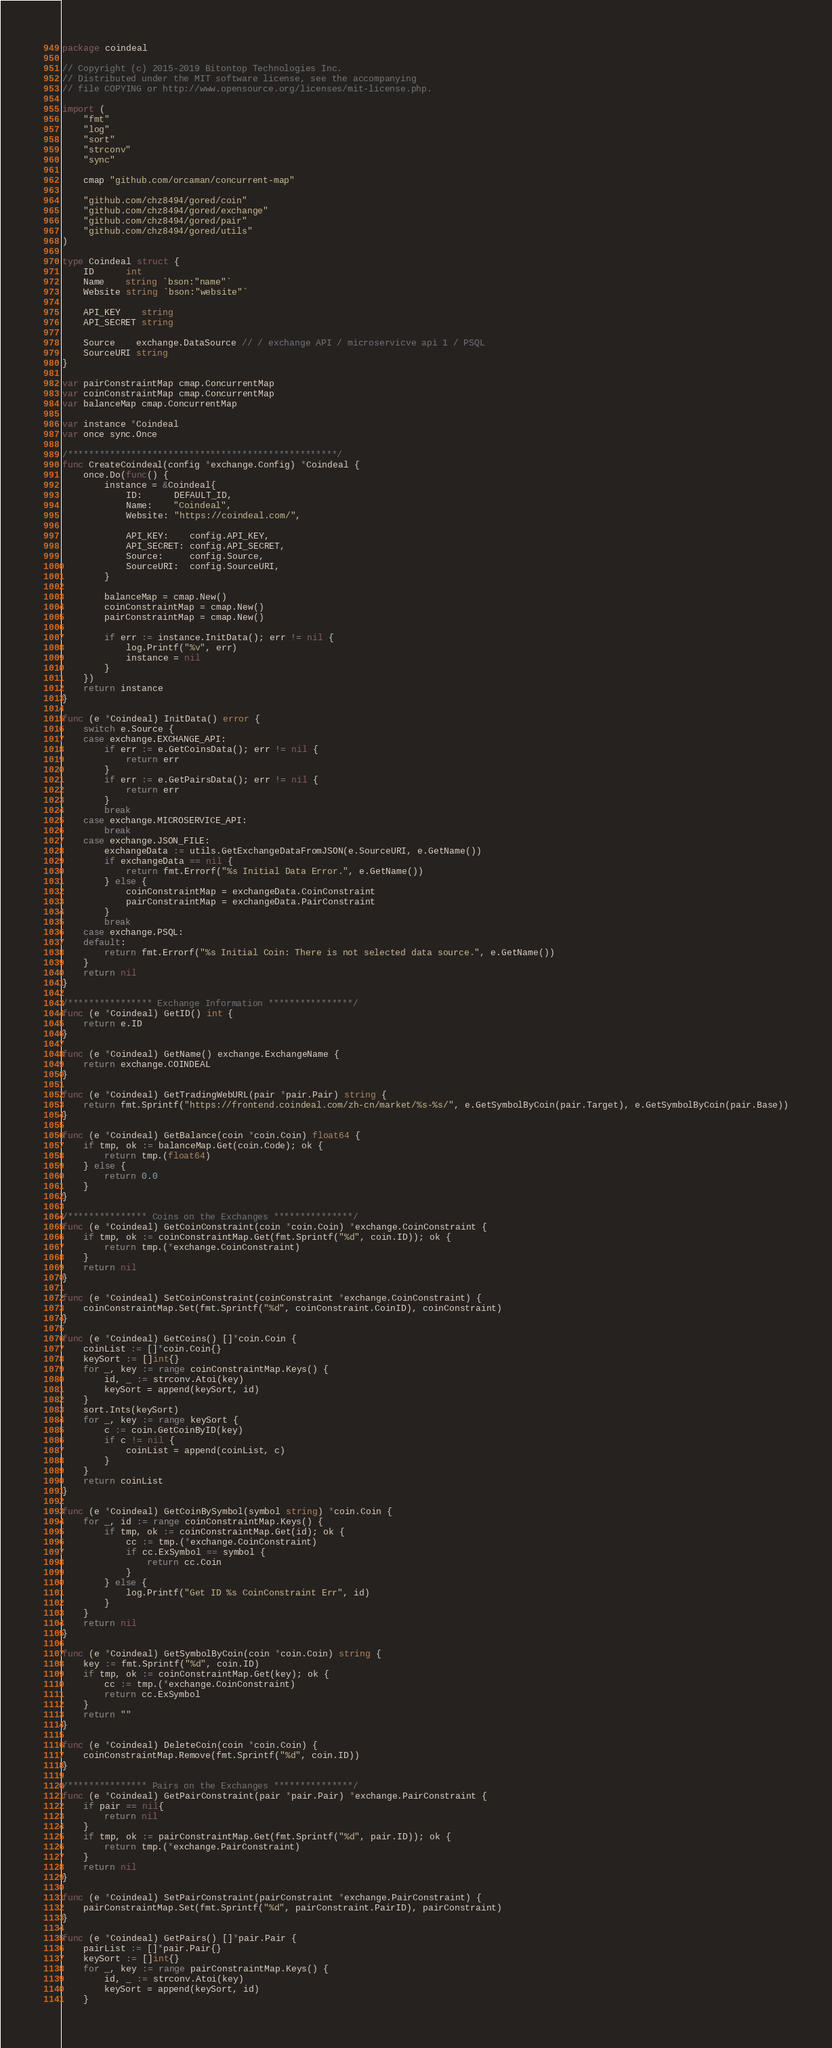<code> <loc_0><loc_0><loc_500><loc_500><_Go_>package coindeal

// Copyright (c) 2015-2019 Bitontop Technologies Inc.
// Distributed under the MIT software license, see the accompanying
// file COPYING or http://www.opensource.org/licenses/mit-license.php.

import (
	"fmt"
	"log"
	"sort"
	"strconv"
	"sync"

	cmap "github.com/orcaman/concurrent-map"

	"github.com/chz8494/gored/coin"
	"github.com/chz8494/gored/exchange"
	"github.com/chz8494/gored/pair"
	"github.com/chz8494/gored/utils"
)

type Coindeal struct {
	ID      int
	Name    string `bson:"name"`
	Website string `bson:"website"`

	API_KEY    string
	API_SECRET string

	Source    exchange.DataSource // / exchange API / microservicve api 1 / PSQL
	SourceURI string
}

var pairConstraintMap cmap.ConcurrentMap
var coinConstraintMap cmap.ConcurrentMap
var balanceMap cmap.ConcurrentMap

var instance *Coindeal
var once sync.Once

/***************************************************/
func CreateCoindeal(config *exchange.Config) *Coindeal {
	once.Do(func() {
		instance = &Coindeal{
			ID:      DEFAULT_ID,
			Name:    "Coindeal",
			Website: "https://coindeal.com/",

			API_KEY:    config.API_KEY,
			API_SECRET: config.API_SECRET,
			Source:     config.Source,
			SourceURI:  config.SourceURI,
		}

		balanceMap = cmap.New()
		coinConstraintMap = cmap.New()
		pairConstraintMap = cmap.New()

		if err := instance.InitData(); err != nil {
			log.Printf("%v", err)
			instance = nil
		}
	})
	return instance
}

func (e *Coindeal) InitData() error {
	switch e.Source {
	case exchange.EXCHANGE_API:
		if err := e.GetCoinsData(); err != nil {
			return err
		}
		if err := e.GetPairsData(); err != nil {
			return err
		}
		break
	case exchange.MICROSERVICE_API:
		break
	case exchange.JSON_FILE:
		exchangeData := utils.GetExchangeDataFromJSON(e.SourceURI, e.GetName())
		if exchangeData == nil {
			return fmt.Errorf("%s Initial Data Error.", e.GetName())
		} else {
			coinConstraintMap = exchangeData.CoinConstraint
			pairConstraintMap = exchangeData.PairConstraint
		}
		break
	case exchange.PSQL:
	default:
		return fmt.Errorf("%s Initial Coin: There is not selected data source.", e.GetName())
	}
	return nil
}

/**************** Exchange Information ****************/
func (e *Coindeal) GetID() int {
	return e.ID
}

func (e *Coindeal) GetName() exchange.ExchangeName {
	return exchange.COINDEAL
}

func (e *Coindeal) GetTradingWebURL(pair *pair.Pair) string {
	return fmt.Sprintf("https://frontend.coindeal.com/zh-cn/market/%s-%s/", e.GetSymbolByCoin(pair.Target), e.GetSymbolByCoin(pair.Base))
}

func (e *Coindeal) GetBalance(coin *coin.Coin) float64 {
	if tmp, ok := balanceMap.Get(coin.Code); ok {
		return tmp.(float64)
	} else {
		return 0.0
	}
}

/*************** Coins on the Exchanges ***************/
func (e *Coindeal) GetCoinConstraint(coin *coin.Coin) *exchange.CoinConstraint {
	if tmp, ok := coinConstraintMap.Get(fmt.Sprintf("%d", coin.ID)); ok {
		return tmp.(*exchange.CoinConstraint)
	}
	return nil
}

func (e *Coindeal) SetCoinConstraint(coinConstraint *exchange.CoinConstraint) {
	coinConstraintMap.Set(fmt.Sprintf("%d", coinConstraint.CoinID), coinConstraint)
}

func (e *Coindeal) GetCoins() []*coin.Coin {
	coinList := []*coin.Coin{}
	keySort := []int{}
	for _, key := range coinConstraintMap.Keys() {
		id, _ := strconv.Atoi(key)
		keySort = append(keySort, id)
	}
	sort.Ints(keySort)
	for _, key := range keySort {
		c := coin.GetCoinByID(key)
		if c != nil {
			coinList = append(coinList, c)
		}
	}
	return coinList
}

func (e *Coindeal) GetCoinBySymbol(symbol string) *coin.Coin {
	for _, id := range coinConstraintMap.Keys() {
		if tmp, ok := coinConstraintMap.Get(id); ok {
			cc := tmp.(*exchange.CoinConstraint)
			if cc.ExSymbol == symbol {
				return cc.Coin
			}
		} else {
			log.Printf("Get ID %s CoinConstraint Err", id)
		}
	}
	return nil
}

func (e *Coindeal) GetSymbolByCoin(coin *coin.Coin) string {
	key := fmt.Sprintf("%d", coin.ID)
	if tmp, ok := coinConstraintMap.Get(key); ok {
		cc := tmp.(*exchange.CoinConstraint)
		return cc.ExSymbol
	}
	return ""
}

func (e *Coindeal) DeleteCoin(coin *coin.Coin) {
	coinConstraintMap.Remove(fmt.Sprintf("%d", coin.ID))
}

/*************** Pairs on the Exchanges ***************/
func (e *Coindeal) GetPairConstraint(pair *pair.Pair) *exchange.PairConstraint {
	if pair == nil{
		return nil
	}
	if tmp, ok := pairConstraintMap.Get(fmt.Sprintf("%d", pair.ID)); ok {
		return tmp.(*exchange.PairConstraint)
	}
	return nil
}

func (e *Coindeal) SetPairConstraint(pairConstraint *exchange.PairConstraint) {
	pairConstraintMap.Set(fmt.Sprintf("%d", pairConstraint.PairID), pairConstraint)
}

func (e *Coindeal) GetPairs() []*pair.Pair {
	pairList := []*pair.Pair{}
	keySort := []int{}
	for _, key := range pairConstraintMap.Keys() {
		id, _ := strconv.Atoi(key)
		keySort = append(keySort, id)
	}</code> 